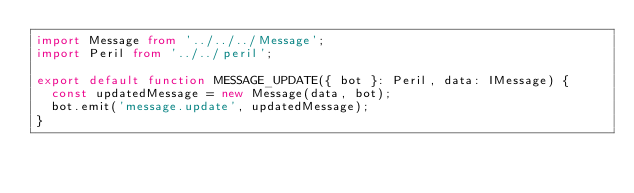<code> <loc_0><loc_0><loc_500><loc_500><_TypeScript_>import Message from '../../../Message';
import Peril from '../../peril';

export default function MESSAGE_UPDATE({ bot }: Peril, data: IMessage) {
	const updatedMessage = new Message(data, bot);
	bot.emit('message.update', updatedMessage);
}
</code> 